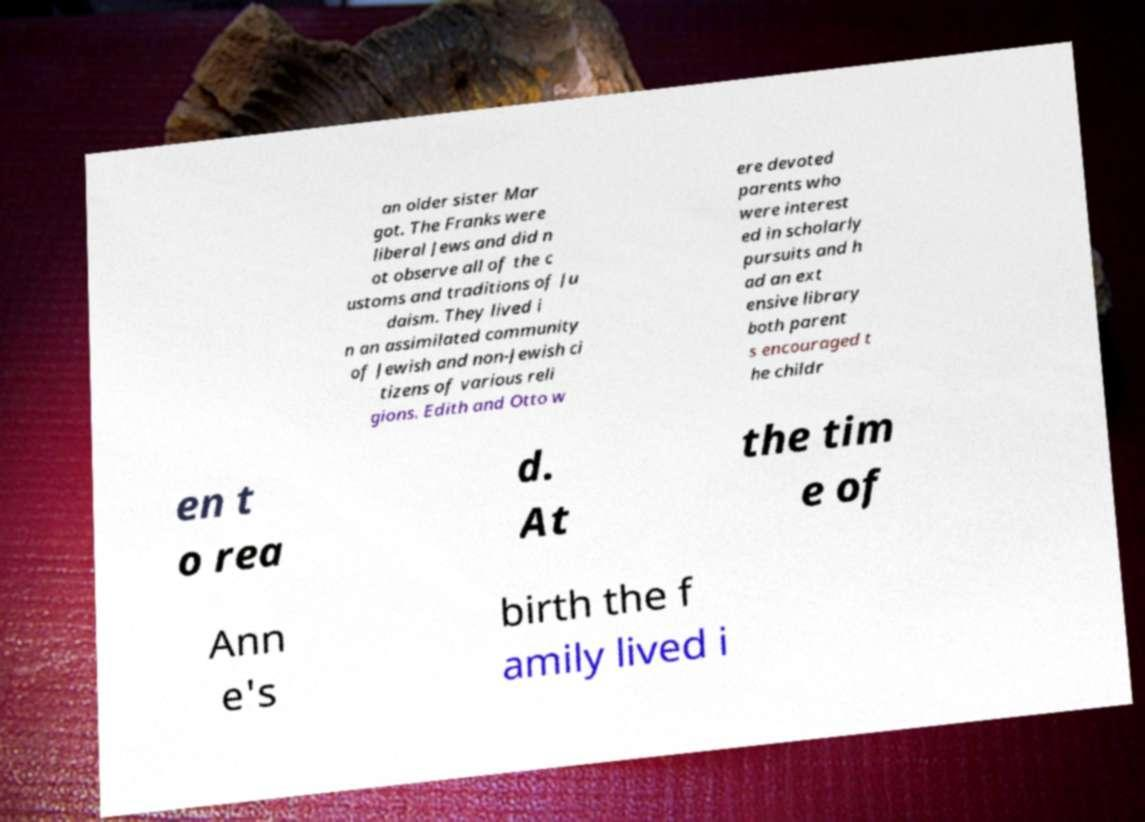Can you read and provide the text displayed in the image?This photo seems to have some interesting text. Can you extract and type it out for me? an older sister Mar got. The Franks were liberal Jews and did n ot observe all of the c ustoms and traditions of Ju daism. They lived i n an assimilated community of Jewish and non-Jewish ci tizens of various reli gions. Edith and Otto w ere devoted parents who were interest ed in scholarly pursuits and h ad an ext ensive library both parent s encouraged t he childr en t o rea d. At the tim e of Ann e's birth the f amily lived i 